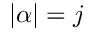Convert formula to latex. <formula><loc_0><loc_0><loc_500><loc_500>| \alpha | = j</formula> 